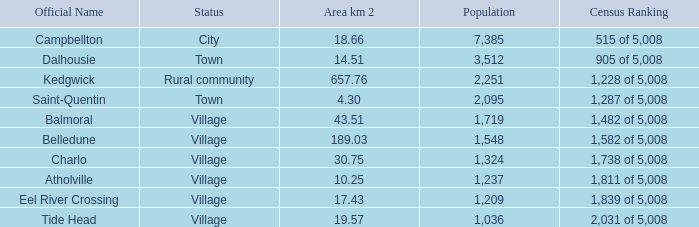When the status is rural community what's the lowest area in kilometers squared? 657.76. 